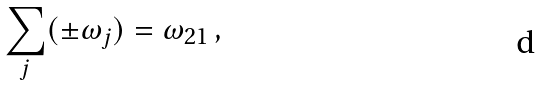Convert formula to latex. <formula><loc_0><loc_0><loc_500><loc_500>\sum _ { j } ( \pm \omega _ { j } ) = \omega _ { 2 1 } \, ,</formula> 